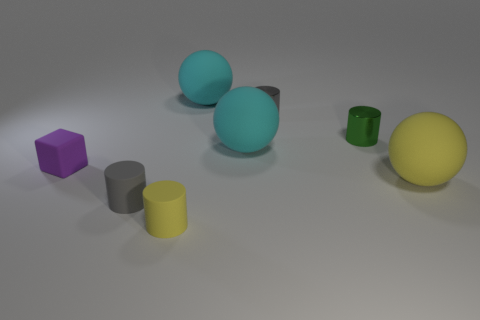Subtract all blue spheres. How many gray cylinders are left? 2 Subtract all cyan cylinders. Subtract all purple cubes. How many cylinders are left? 4 Add 1 green metallic balls. How many objects exist? 9 Subtract all big gray metallic cylinders. Subtract all green cylinders. How many objects are left? 7 Add 7 large yellow balls. How many large yellow balls are left? 8 Add 4 gray things. How many gray things exist? 6 Subtract 1 yellow spheres. How many objects are left? 7 Subtract all spheres. How many objects are left? 5 